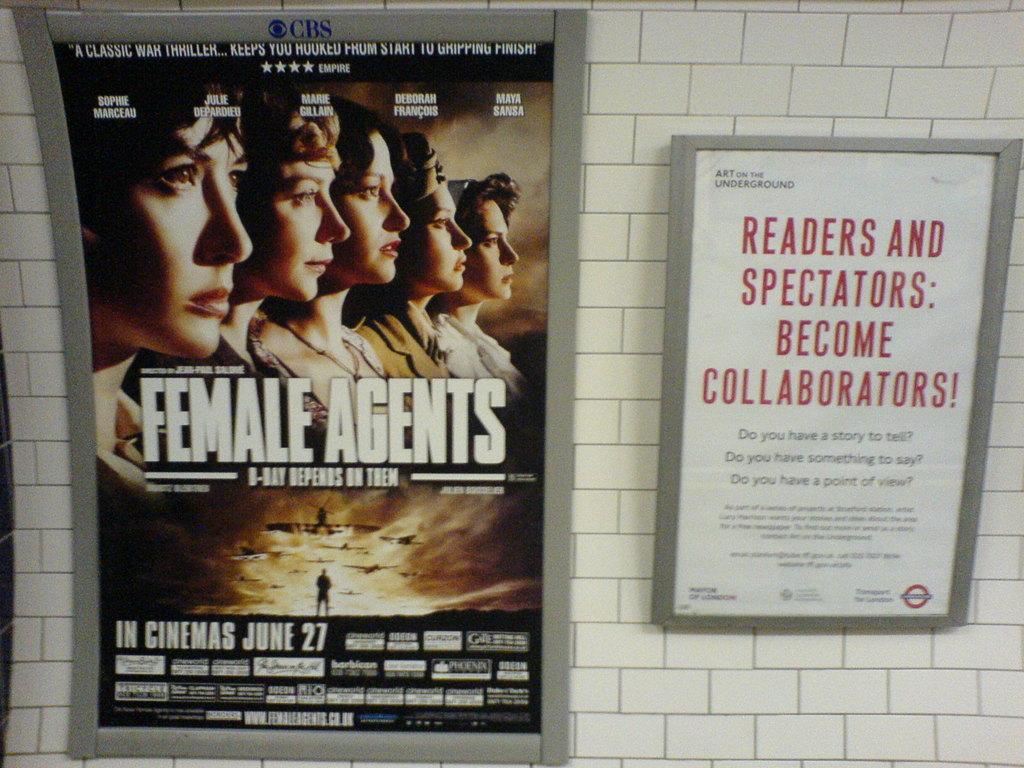What is the name of the film on the poster?
Your response must be concise. Female agents. 